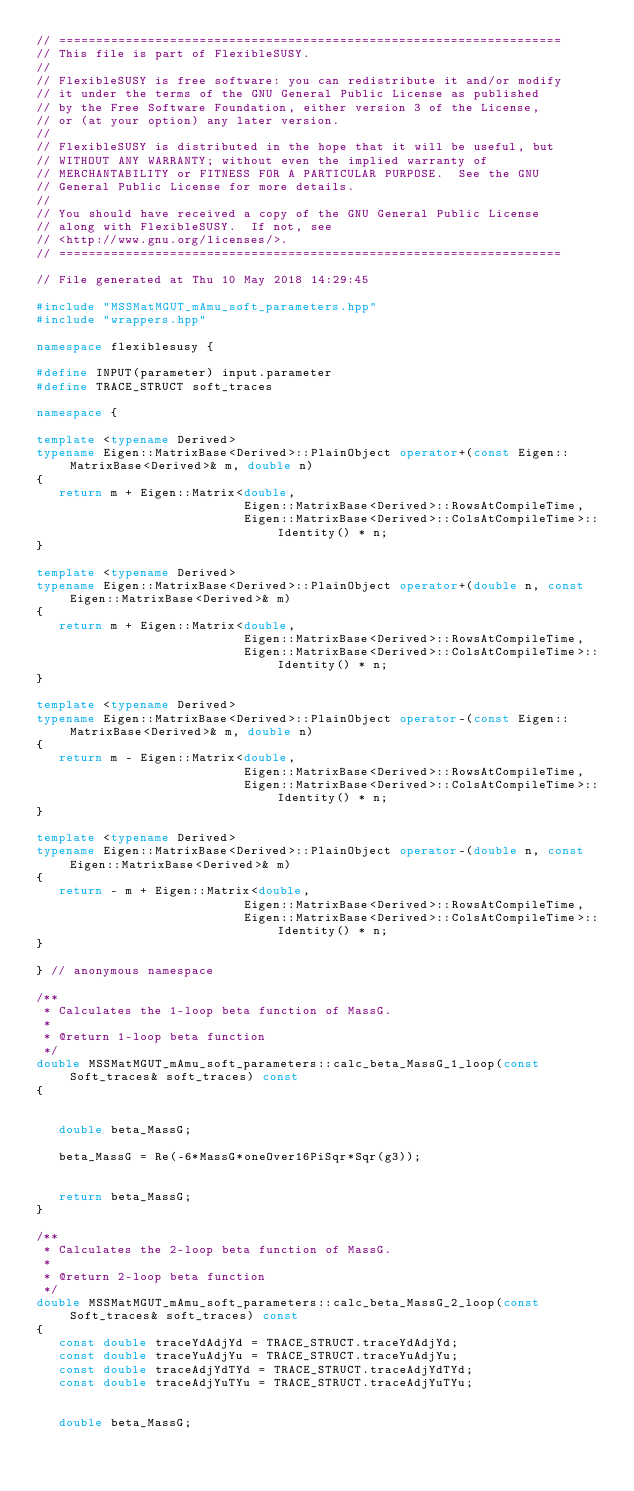Convert code to text. <code><loc_0><loc_0><loc_500><loc_500><_C++_>// ====================================================================
// This file is part of FlexibleSUSY.
//
// FlexibleSUSY is free software: you can redistribute it and/or modify
// it under the terms of the GNU General Public License as published
// by the Free Software Foundation, either version 3 of the License,
// or (at your option) any later version.
//
// FlexibleSUSY is distributed in the hope that it will be useful, but
// WITHOUT ANY WARRANTY; without even the implied warranty of
// MERCHANTABILITY or FITNESS FOR A PARTICULAR PURPOSE.  See the GNU
// General Public License for more details.
//
// You should have received a copy of the GNU General Public License
// along with FlexibleSUSY.  If not, see
// <http://www.gnu.org/licenses/>.
// ====================================================================

// File generated at Thu 10 May 2018 14:29:45

#include "MSSMatMGUT_mAmu_soft_parameters.hpp"
#include "wrappers.hpp"

namespace flexiblesusy {

#define INPUT(parameter) input.parameter
#define TRACE_STRUCT soft_traces

namespace {

template <typename Derived>
typename Eigen::MatrixBase<Derived>::PlainObject operator+(const Eigen::MatrixBase<Derived>& m, double n)
{
   return m + Eigen::Matrix<double,
                            Eigen::MatrixBase<Derived>::RowsAtCompileTime,
                            Eigen::MatrixBase<Derived>::ColsAtCompileTime>::Identity() * n;
}

template <typename Derived>
typename Eigen::MatrixBase<Derived>::PlainObject operator+(double n, const Eigen::MatrixBase<Derived>& m)
{
   return m + Eigen::Matrix<double,
                            Eigen::MatrixBase<Derived>::RowsAtCompileTime,
                            Eigen::MatrixBase<Derived>::ColsAtCompileTime>::Identity() * n;
}

template <typename Derived>
typename Eigen::MatrixBase<Derived>::PlainObject operator-(const Eigen::MatrixBase<Derived>& m, double n)
{
   return m - Eigen::Matrix<double,
                            Eigen::MatrixBase<Derived>::RowsAtCompileTime,
                            Eigen::MatrixBase<Derived>::ColsAtCompileTime>::Identity() * n;
}

template <typename Derived>
typename Eigen::MatrixBase<Derived>::PlainObject operator-(double n, const Eigen::MatrixBase<Derived>& m)
{
   return - m + Eigen::Matrix<double,
                            Eigen::MatrixBase<Derived>::RowsAtCompileTime,
                            Eigen::MatrixBase<Derived>::ColsAtCompileTime>::Identity() * n;
}

} // anonymous namespace

/**
 * Calculates the 1-loop beta function of MassG.
 *
 * @return 1-loop beta function
 */
double MSSMatMGUT_mAmu_soft_parameters::calc_beta_MassG_1_loop(const Soft_traces& soft_traces) const
{


   double beta_MassG;

   beta_MassG = Re(-6*MassG*oneOver16PiSqr*Sqr(g3));


   return beta_MassG;
}

/**
 * Calculates the 2-loop beta function of MassG.
 *
 * @return 2-loop beta function
 */
double MSSMatMGUT_mAmu_soft_parameters::calc_beta_MassG_2_loop(const Soft_traces& soft_traces) const
{
   const double traceYdAdjYd = TRACE_STRUCT.traceYdAdjYd;
   const double traceYuAdjYu = TRACE_STRUCT.traceYuAdjYu;
   const double traceAdjYdTYd = TRACE_STRUCT.traceAdjYdTYd;
   const double traceAdjYuTYu = TRACE_STRUCT.traceAdjYuTYu;


   double beta_MassG;
</code> 